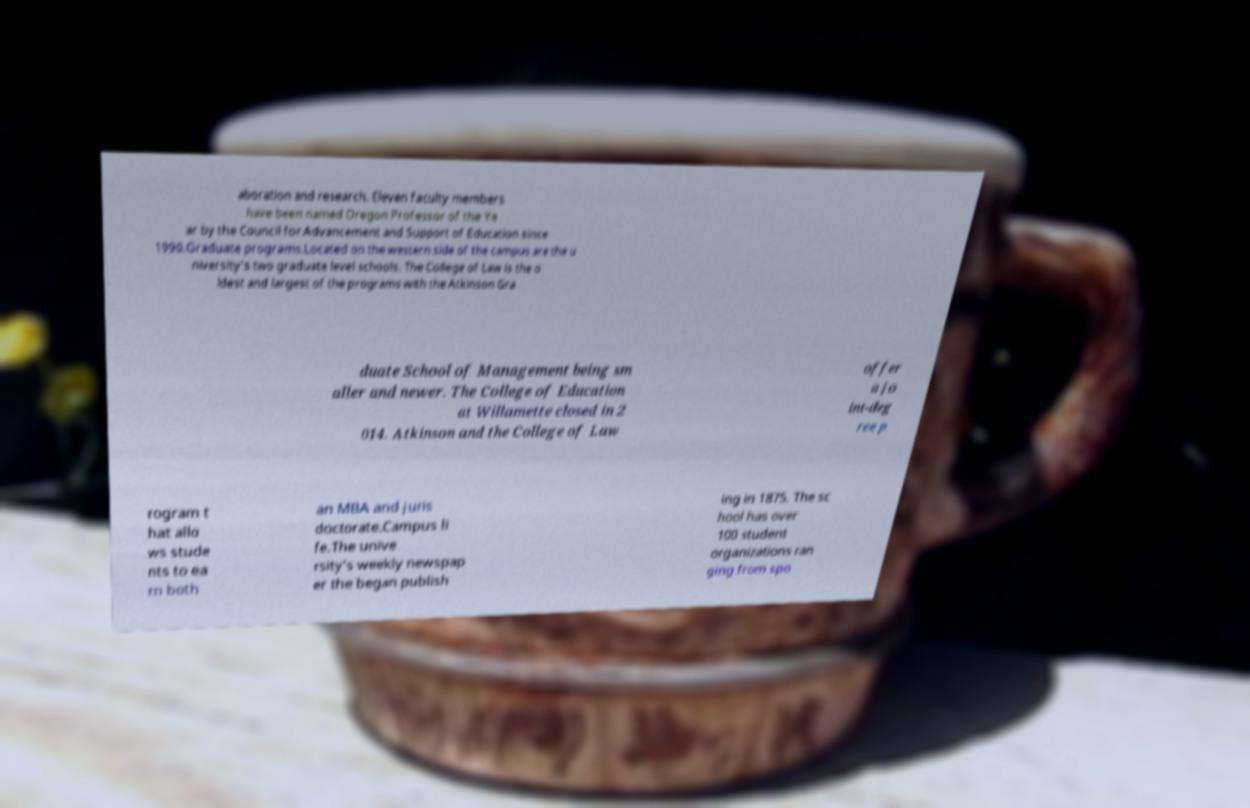Could you assist in decoding the text presented in this image and type it out clearly? aboration and research. Eleven faculty members have been named Oregon Professor of the Ye ar by the Council for Advancement and Support of Education since 1990.Graduate programs.Located on the western side of the campus are the u niversity's two graduate level schools. The College of Law is the o ldest and largest of the programs with the Atkinson Gra duate School of Management being sm aller and newer. The College of Education at Willamette closed in 2 014. Atkinson and the College of Law offer a jo int-deg ree p rogram t hat allo ws stude nts to ea rn both an MBA and juris doctorate.Campus li fe.The unive rsity's weekly newspap er the began publish ing in 1875. The sc hool has over 100 student organizations ran ging from spo 